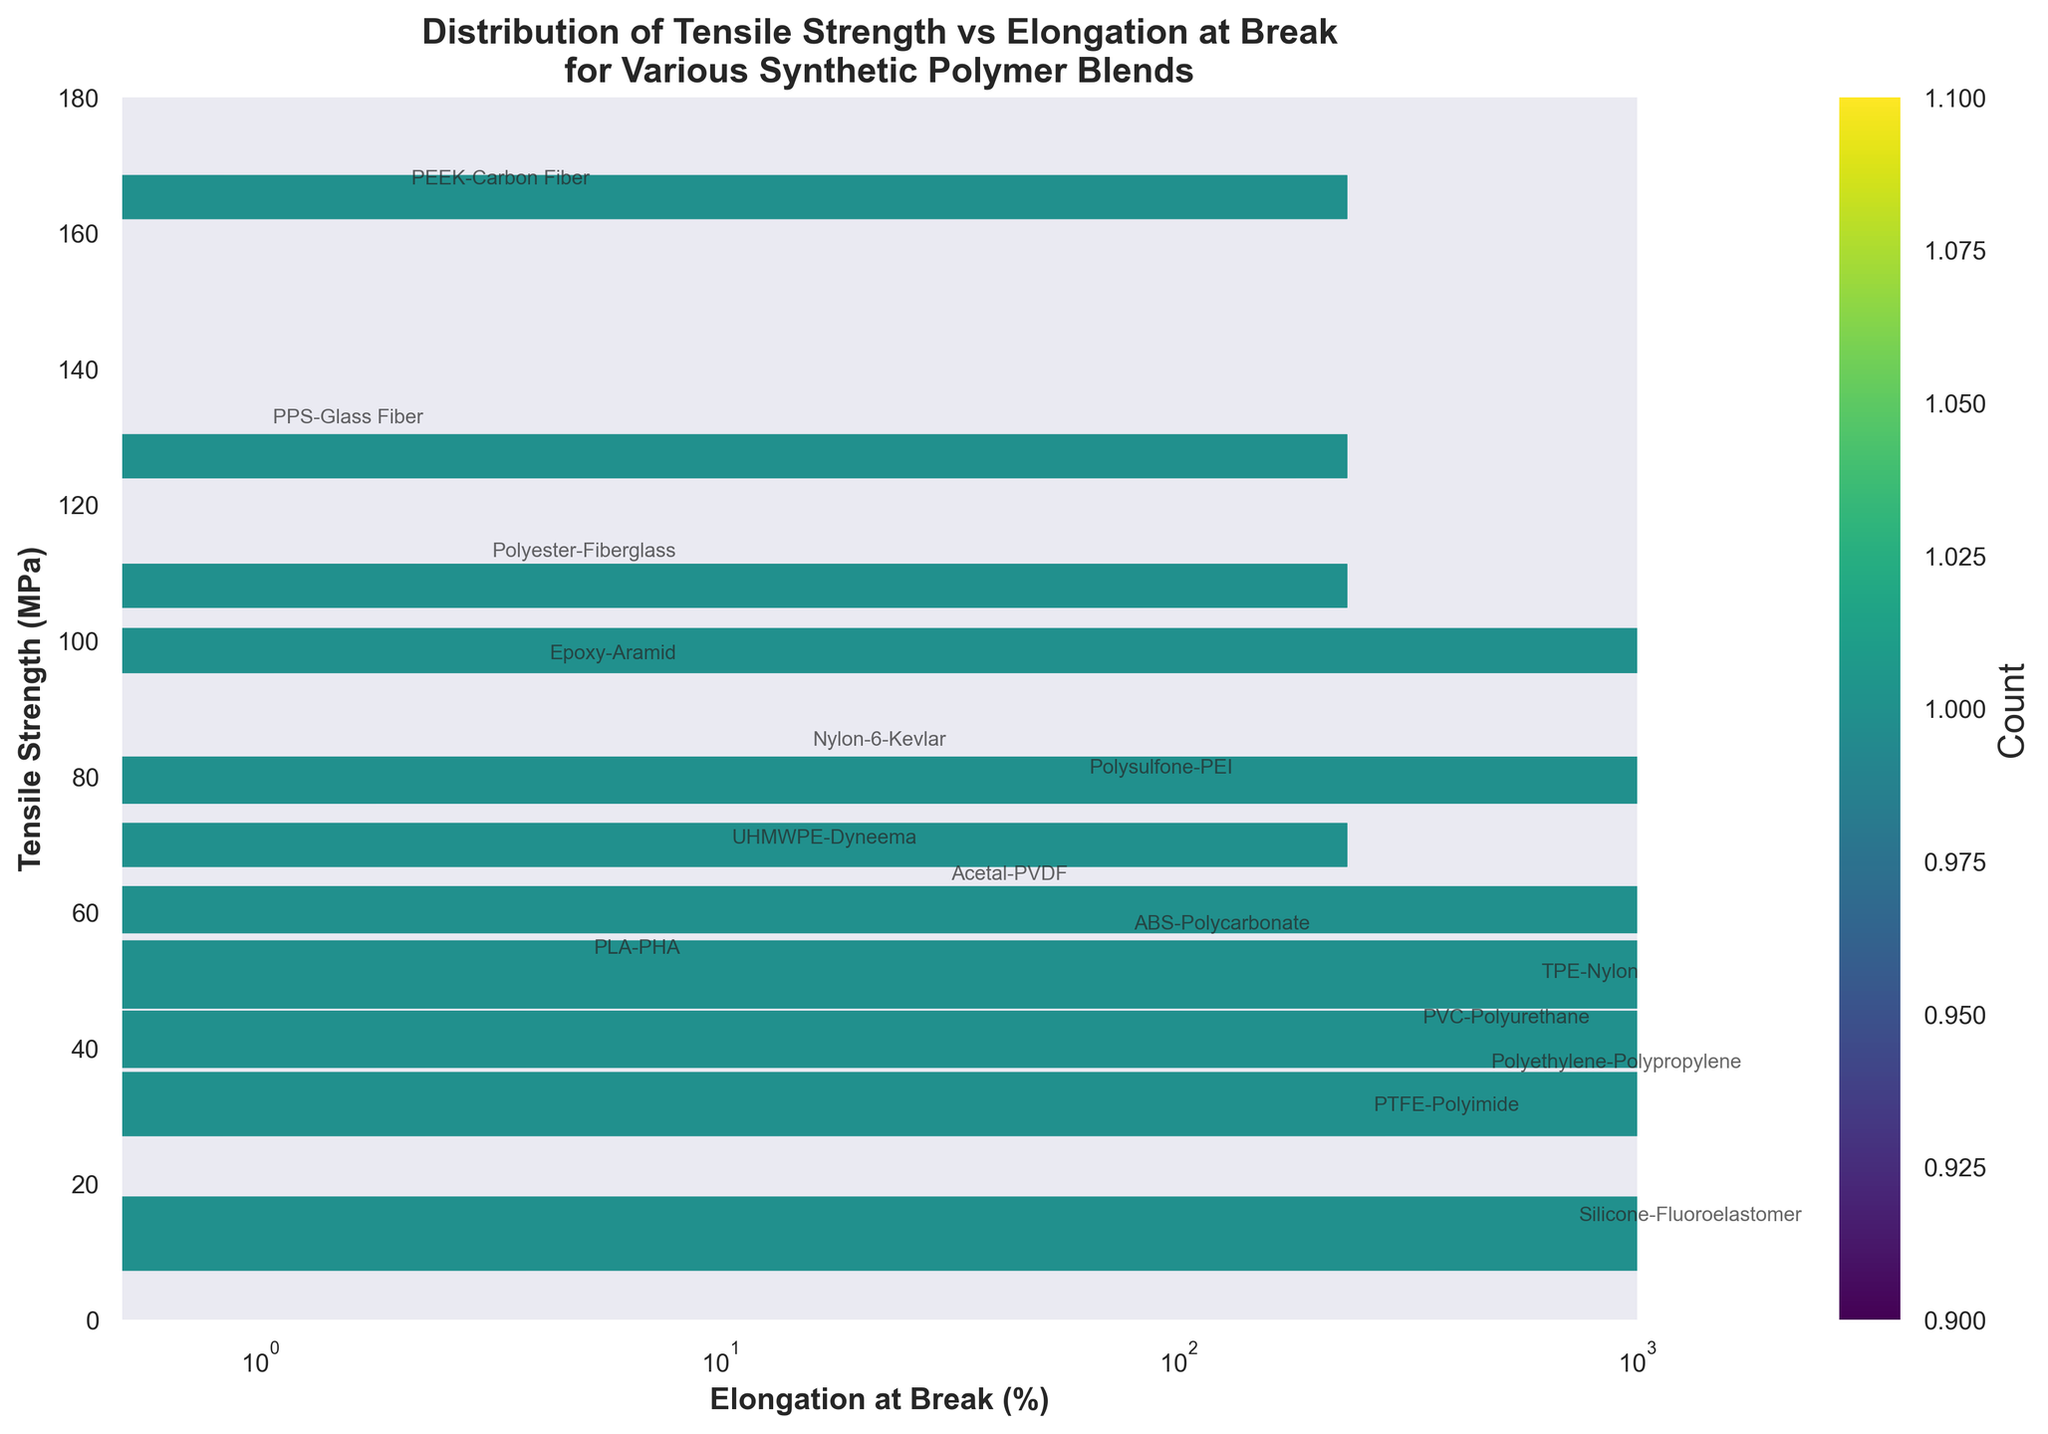What is the title of the plot? The title is found at the top of the plot and provides a summary of what the plot is about, which is the distribution of tensile strength and elongation at break for synthetic polymer blends.
Answer: Distribution of Tensile Strength vs Elongation at Break for Various Synthetic Polymer Blends What are the axes' labels? The labels are found along the sides of the plot. The x-axis label describes elongation at break percentage, and the y-axis label describes tensile strength in MPa.
Answer: x-axis: Elongation at Break (%); y-axis: Tensile Strength (MPa) How are the polymer blends identified in the plot? Each polymer blend is identified by annotations near their respective data points, showing the polymer names such as Polyethylene-Polypropylene, Nylon-6-Kevlar, etc.
Answer: By annotations How many data points are displayed in the hexbin plot? The hexbin plot contains one hexbin per data point, and the annotations reveal 15 distinct synthetic polymer blends, meaning there are 15 data points.
Answer: 15 Which polymer blend has the highest tensile strength? To determine the polymer with the highest tensile strength, look for the highest y-value in the annotations. PEEK-Carbon Fiber has the highest tensile strength annotated at 165.3 MPa.
Answer: PEEK-Carbon Fiber What is the range of the x-axis? The x-axis range is indicated by the x-axis limits. It spans from 0.5% to 1000% elongation at break.
Answer: 0.5 to 1000 What is the trend between tensile strength and elongation at break? Observing the plot, the distribution generally shows that as tensile strength increases, elongation at break decreases. Most high tensile strength materials have low elongation at break.
Answer: Inverse relationship Which polymer blend combines high tensile strength with high elongation at break? High tensile strength and high elongation at break would have high values on both axes. TPE-Nylon shows a notable combination with 48.5 MPa (moderate tensile strength) and 580% elongation at break.
Answer: TPE-Nylon How does ABS-Polycarbonate compare to PLA-PHA in terms of tensile strength? ABS-Polycarbonate and PLA-PHA can be compared by their y-values. ABS-Polycarbonate has a tensile strength of 55.6 MPa, whereas PLA-PHA has 52.1 MPa, making ABS-Polycarbonate slightly stronger.
Answer: ABS-Polycarbonate is stronger Which polymer blend has the lowest elongation at break and what is its tensile strength? Polyamide-imide (PEEK)-Carbon Fiber has the lowest elongation at break of 2%, as noted in the plot annotations, and its tensile strength is 165.3 MPa.
Answer: PEEK-Carbon Fiber with 165.3 MPa 